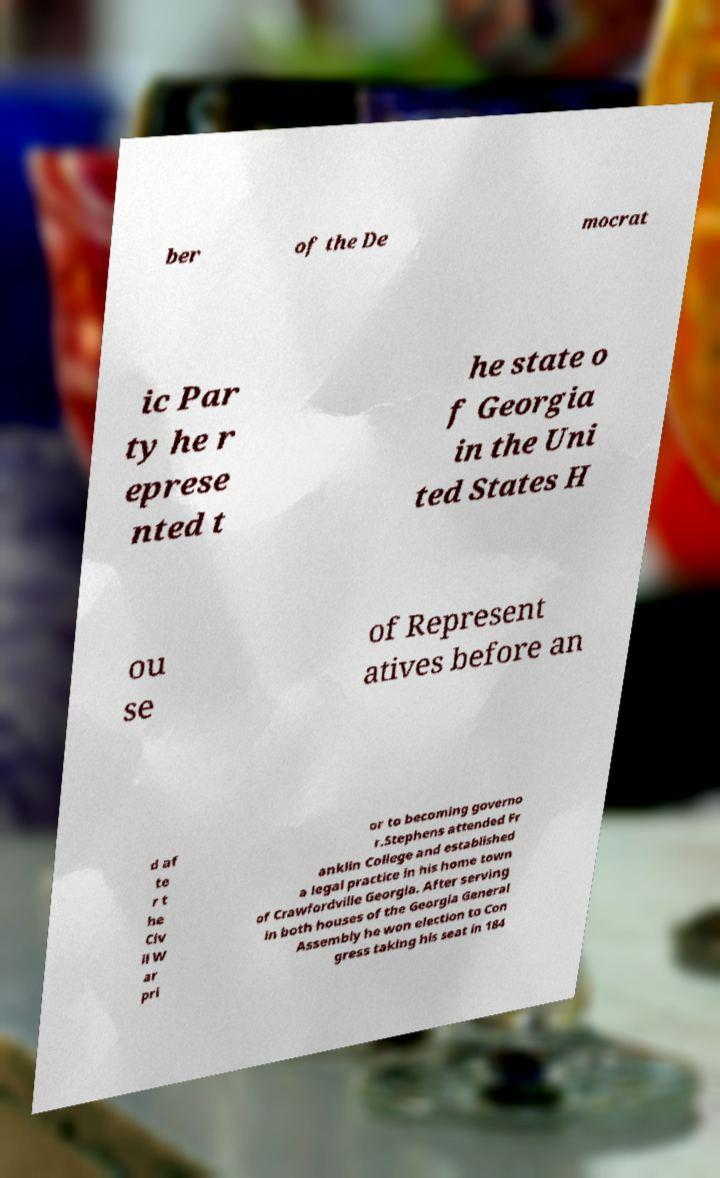Could you assist in decoding the text presented in this image and type it out clearly? ber of the De mocrat ic Par ty he r eprese nted t he state o f Georgia in the Uni ted States H ou se of Represent atives before an d af te r t he Civ il W ar pri or to becoming governo r.Stephens attended Fr anklin College and established a legal practice in his home town of Crawfordville Georgia. After serving in both houses of the Georgia General Assembly he won election to Con gress taking his seat in 184 